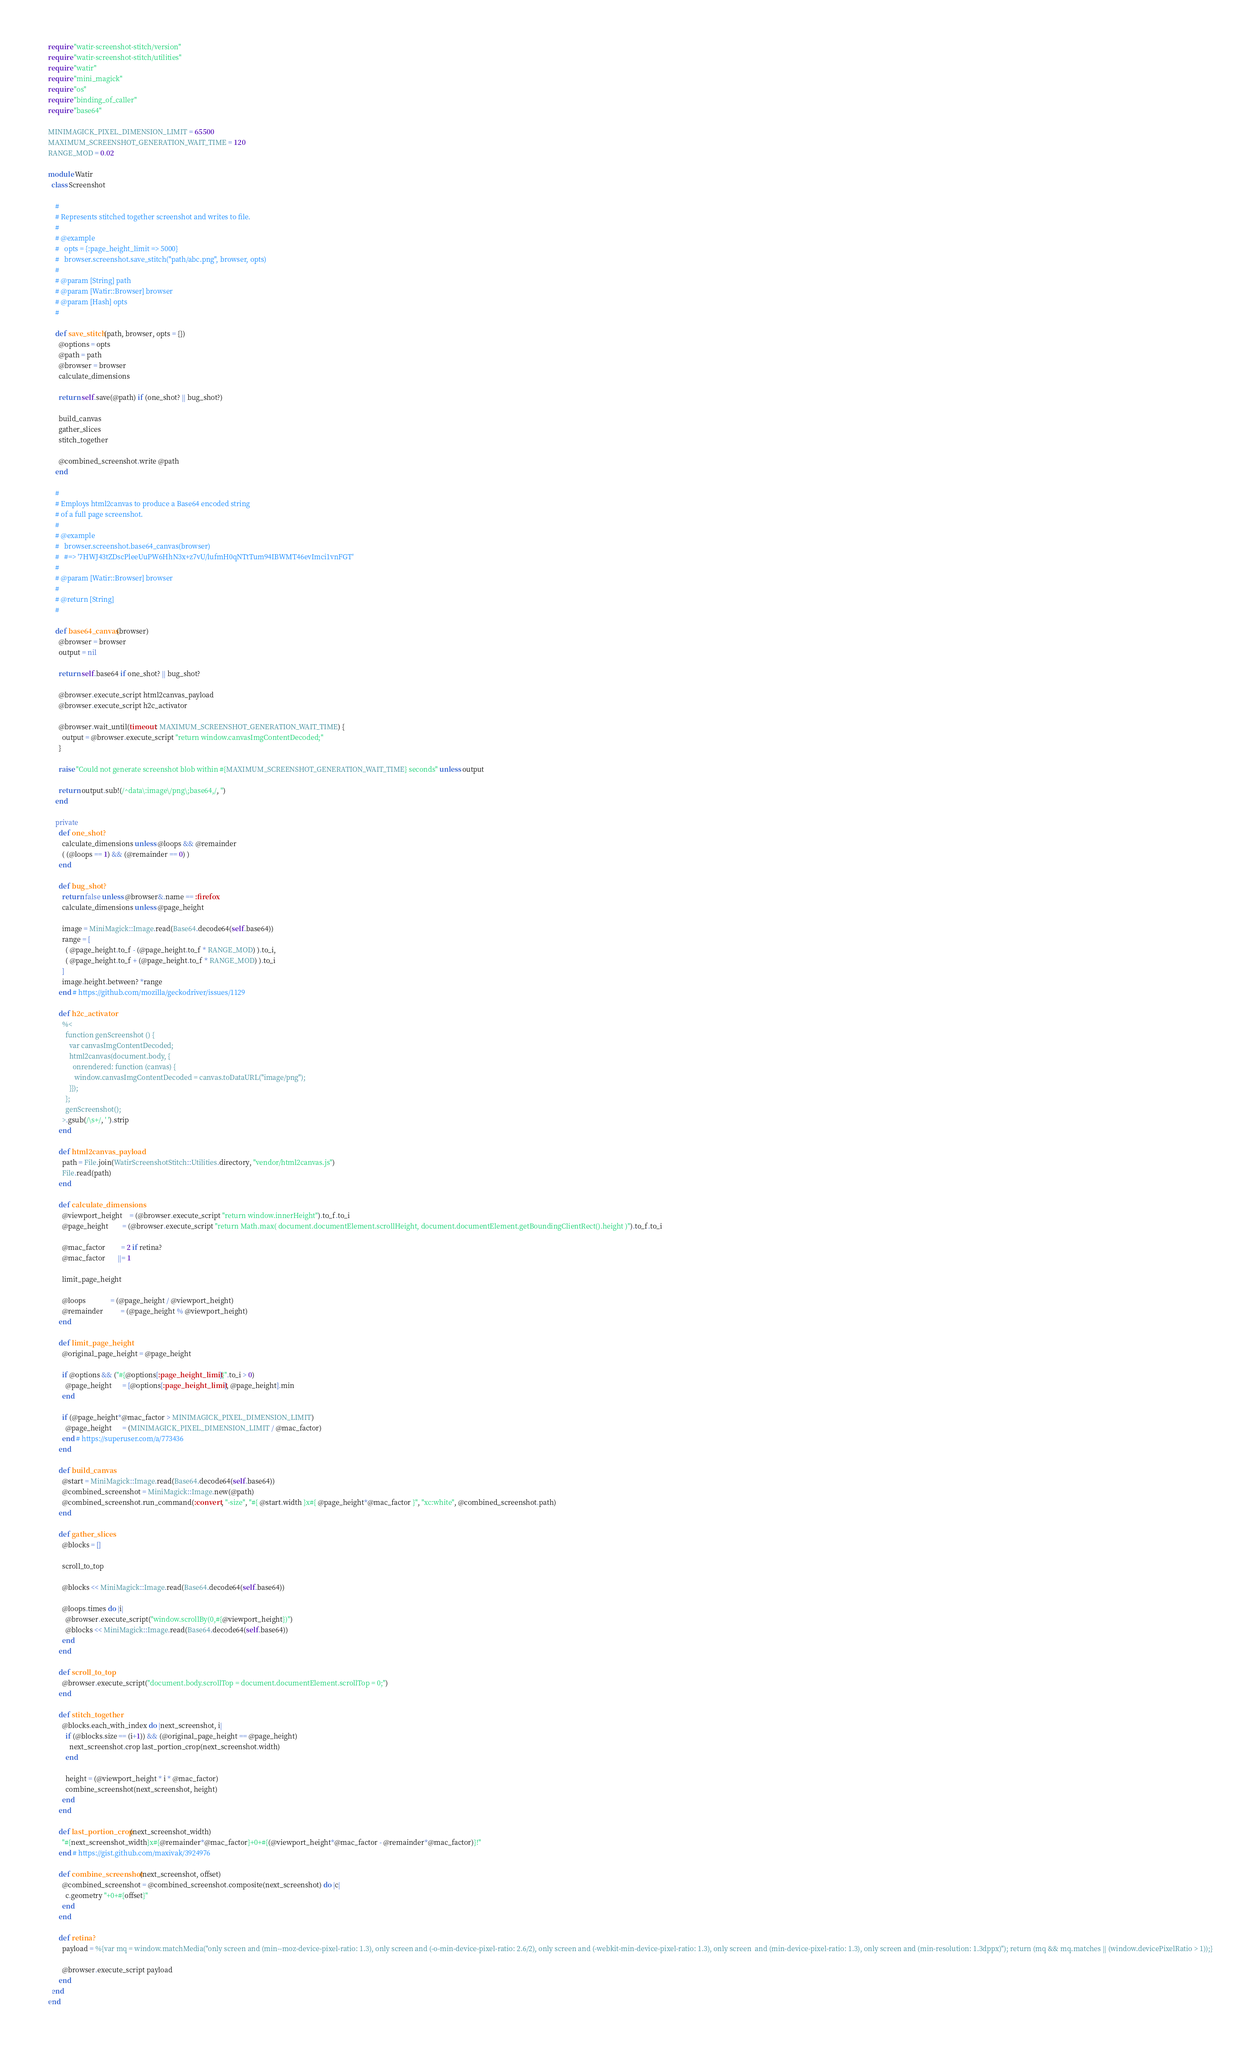<code> <loc_0><loc_0><loc_500><loc_500><_Ruby_>require "watir-screenshot-stitch/version"
require "watir-screenshot-stitch/utilities"
require "watir"
require "mini_magick"
require "os"
require "binding_of_caller"
require "base64"

MINIMAGICK_PIXEL_DIMENSION_LIMIT = 65500
MAXIMUM_SCREENSHOT_GENERATION_WAIT_TIME = 120
RANGE_MOD = 0.02

module Watir
  class Screenshot

    #
    # Represents stitched together screenshot and writes to file.
    #
    # @example
    #   opts = {:page_height_limit => 5000}
    #   browser.screenshot.save_stitch("path/abc.png", browser, opts)
    #
    # @param [String] path
    # @param [Watir::Browser] browser
    # @param [Hash] opts
    #

    def save_stitch(path, browser, opts = {})
      @options = opts
      @path = path
      @browser = browser
      calculate_dimensions

      return self.save(@path) if (one_shot? || bug_shot?)

      build_canvas
      gather_slices
      stitch_together

      @combined_screenshot.write @path
    end

    #
    # Employs html2canvas to produce a Base64 encoded string
    # of a full page screenshot.
    #
    # @example
    #   browser.screenshot.base64_canvas(browser)
    #   #=> '7HWJ43tZDscPleeUuPW6HhN3x+z7vU/lufmH0qNTtTum94IBWMT46evImci1vnFGT'
    #
    # @param [Watir::Browser] browser
    #
    # @return [String]
    #

    def base64_canvas(browser)
      @browser = browser
      output = nil

      return self.base64 if one_shot? || bug_shot?

      @browser.execute_script html2canvas_payload
      @browser.execute_script h2c_activator

      @browser.wait_until(timeout: MAXIMUM_SCREENSHOT_GENERATION_WAIT_TIME) {
        output = @browser.execute_script "return window.canvasImgContentDecoded;"
      }

      raise "Could not generate screenshot blob within #{MAXIMUM_SCREENSHOT_GENERATION_WAIT_TIME} seconds" unless output

      return output.sub!(/^data\:image\/png\;base64,/, '')
    end

    private
      def one_shot?
        calculate_dimensions unless @loops && @remainder
        ( (@loops == 1) && (@remainder == 0) )
      end

      def bug_shot?
        return false unless @browser&.name == :firefox
        calculate_dimensions unless @page_height

        image = MiniMagick::Image.read(Base64.decode64(self.base64))
        range = [
          ( @page_height.to_f - (@page_height.to_f * RANGE_MOD) ).to_i,
          ( @page_height.to_f + (@page_height.to_f * RANGE_MOD) ).to_i
        ]
        image.height.between? *range
      end # https://github.com/mozilla/geckodriver/issues/1129

      def h2c_activator
        %<
          function genScreenshot () {
            var canvasImgContentDecoded;
            html2canvas(document.body, {
              onrendered: function (canvas) {
               window.canvasImgContentDecoded = canvas.toDataURL("image/png");
            }});
          };
          genScreenshot();
        >.gsub(/\s+/, ' ').strip
      end

      def html2canvas_payload
        path = File.join(WatirScreenshotStitch::Utilities.directory, "vendor/html2canvas.js")
        File.read(path)
      end

      def calculate_dimensions
        @viewport_height    = (@browser.execute_script "return window.innerHeight").to_f.to_i
        @page_height        = (@browser.execute_script "return Math.max( document.documentElement.scrollHeight, document.documentElement.getBoundingClientRect().height )").to_f.to_i

        @mac_factor         = 2 if retina?
        @mac_factor       ||= 1

        limit_page_height

        @loops              = (@page_height / @viewport_height)
        @remainder          = (@page_height % @viewport_height)
      end

      def limit_page_height
        @original_page_height = @page_height

        if @options && ("#{@options[:page_height_limit]}".to_i > 0)
          @page_height      = [@options[:page_height_limit], @page_height].min
        end

        if (@page_height*@mac_factor > MINIMAGICK_PIXEL_DIMENSION_LIMIT)
          @page_height      = (MINIMAGICK_PIXEL_DIMENSION_LIMIT / @mac_factor)
        end # https://superuser.com/a/773436
      end

      def build_canvas
        @start = MiniMagick::Image.read(Base64.decode64(self.base64))
        @combined_screenshot = MiniMagick::Image.new(@path)
        @combined_screenshot.run_command(:convert, "-size", "#{ @start.width }x#{ @page_height*@mac_factor }", "xc:white", @combined_screenshot.path)
      end

      def gather_slices
        @blocks = []

        scroll_to_top

        @blocks << MiniMagick::Image.read(Base64.decode64(self.base64))

        @loops.times do |i|
          @browser.execute_script("window.scrollBy(0,#{@viewport_height})")
          @blocks << MiniMagick::Image.read(Base64.decode64(self.base64))
        end
      end

      def scroll_to_top
        @browser.execute_script("document.body.scrollTop = document.documentElement.scrollTop = 0;")
      end

      def stitch_together
        @blocks.each_with_index do |next_screenshot, i|
          if (@blocks.size == (i+1)) && (@original_page_height == @page_height)
            next_screenshot.crop last_portion_crop(next_screenshot.width)
          end

          height = (@viewport_height * i * @mac_factor)
          combine_screenshot(next_screenshot, height)
        end
      end

      def last_portion_crop(next_screenshot_width)
        "#{next_screenshot_width}x#{@remainder*@mac_factor}+0+#{(@viewport_height*@mac_factor - @remainder*@mac_factor)}!"
      end # https://gist.github.com/maxivak/3924976

      def combine_screenshot(next_screenshot, offset)
        @combined_screenshot = @combined_screenshot.composite(next_screenshot) do |c|
          c.geometry "+0+#{offset}"
        end
      end

      def retina?
        payload = %{var mq = window.matchMedia("only screen and (min--moz-device-pixel-ratio: 1.3), only screen and (-o-min-device-pixel-ratio: 2.6/2), only screen and (-webkit-min-device-pixel-ratio: 1.3), only screen  and (min-device-pixel-ratio: 1.3), only screen and (min-resolution: 1.3dppx)"); return (mq && mq.matches || (window.devicePixelRatio > 1));}

        @browser.execute_script payload
      end
  end
end
</code> 